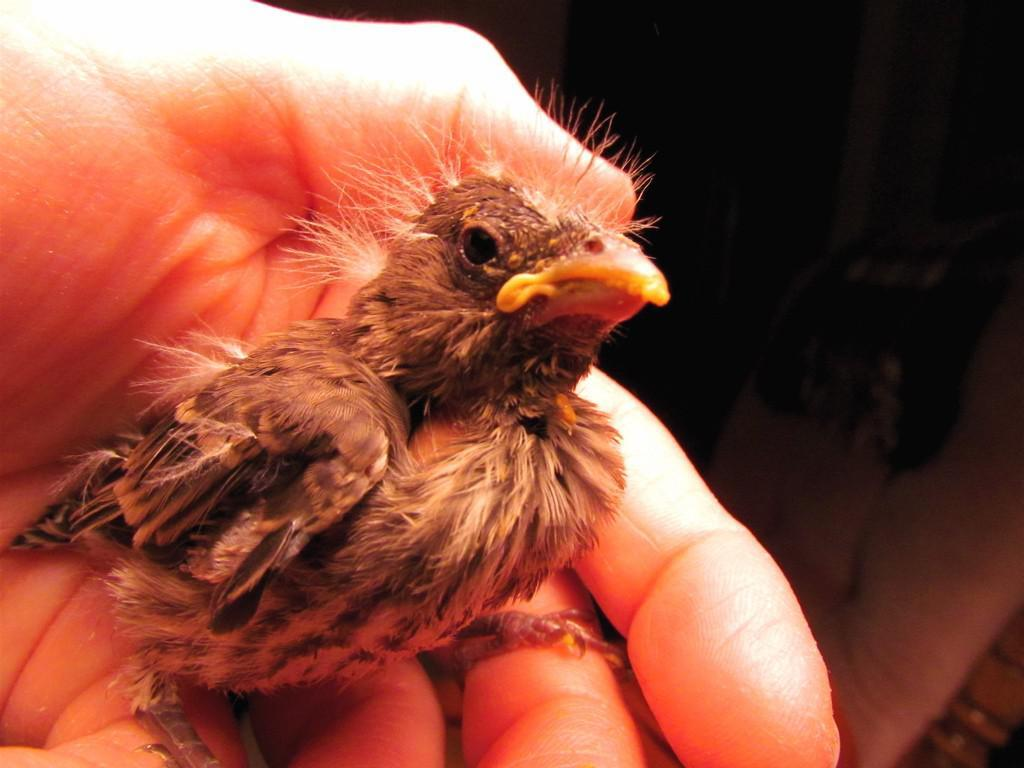What type of animal is in the image? There is a bird in the image. Where is the bird located in the image? The bird is in someone's hand. What color is the gold that the bird is holding in its beak? The bird is not holding any gold in its beak, as there is no gold present in the image. 